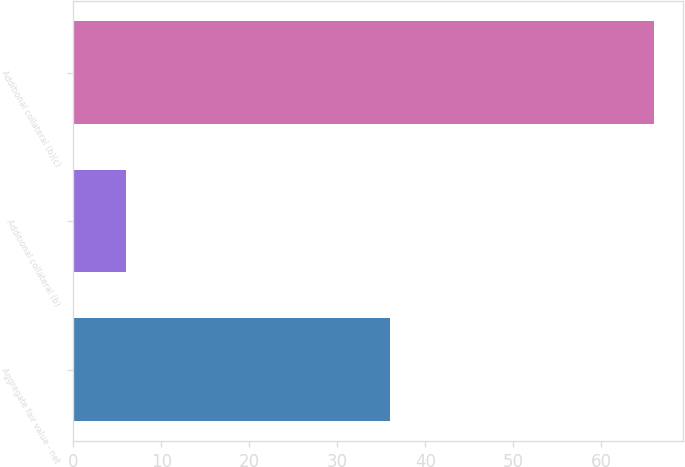<chart> <loc_0><loc_0><loc_500><loc_500><bar_chart><fcel>Aggregate fair value - net<fcel>Additional collateral (b)<fcel>Additional collateral (b)(c)<nl><fcel>36<fcel>6<fcel>66<nl></chart> 